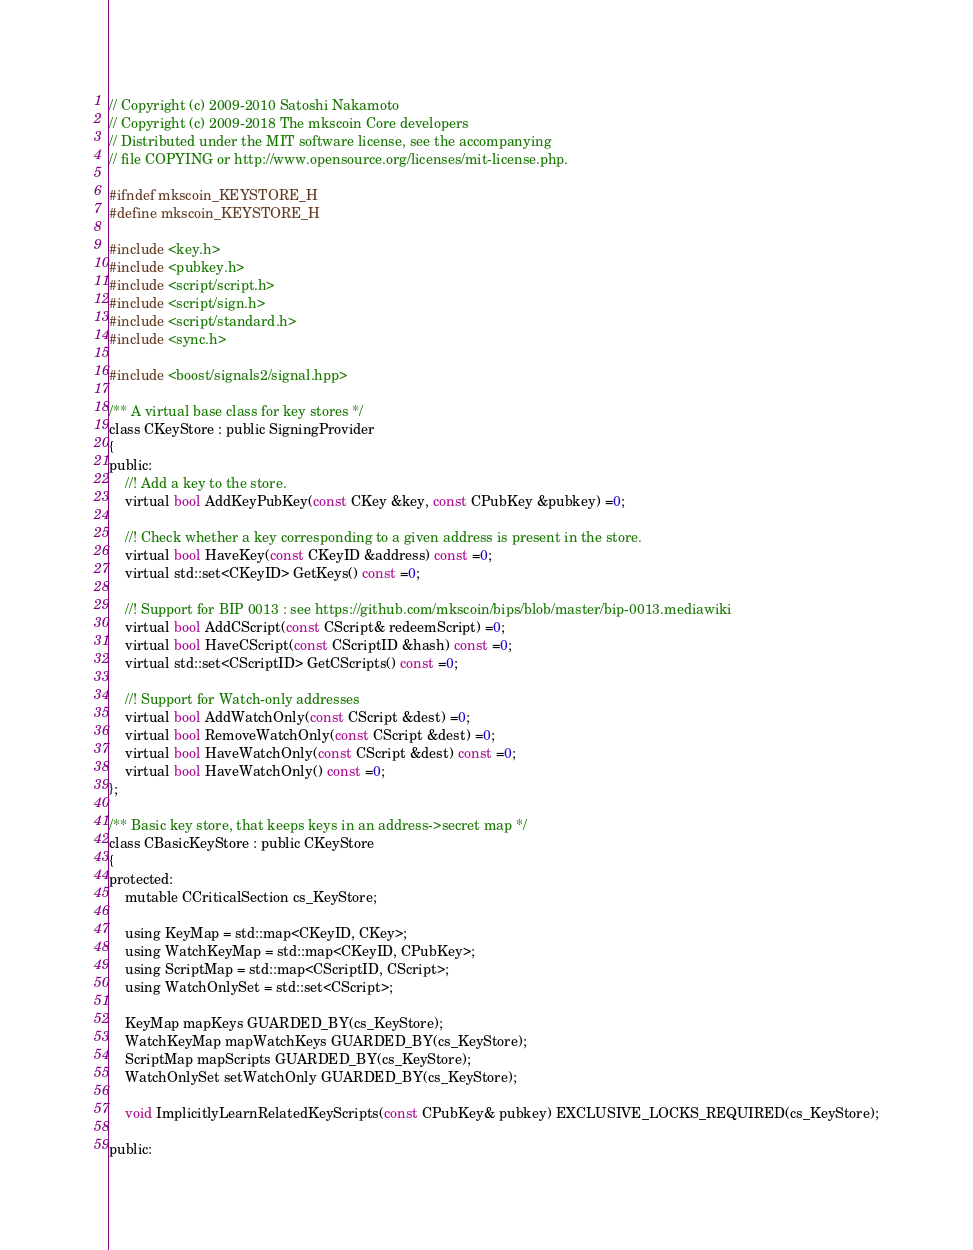<code> <loc_0><loc_0><loc_500><loc_500><_C_>// Copyright (c) 2009-2010 Satoshi Nakamoto
// Copyright (c) 2009-2018 The mkscoin Core developers
// Distributed under the MIT software license, see the accompanying
// file COPYING or http://www.opensource.org/licenses/mit-license.php.

#ifndef mkscoin_KEYSTORE_H
#define mkscoin_KEYSTORE_H

#include <key.h>
#include <pubkey.h>
#include <script/script.h>
#include <script/sign.h>
#include <script/standard.h>
#include <sync.h>

#include <boost/signals2/signal.hpp>

/** A virtual base class for key stores */
class CKeyStore : public SigningProvider
{
public:
    //! Add a key to the store.
    virtual bool AddKeyPubKey(const CKey &key, const CPubKey &pubkey) =0;

    //! Check whether a key corresponding to a given address is present in the store.
    virtual bool HaveKey(const CKeyID &address) const =0;
    virtual std::set<CKeyID> GetKeys() const =0;

    //! Support for BIP 0013 : see https://github.com/mkscoin/bips/blob/master/bip-0013.mediawiki
    virtual bool AddCScript(const CScript& redeemScript) =0;
    virtual bool HaveCScript(const CScriptID &hash) const =0;
    virtual std::set<CScriptID> GetCScripts() const =0;

    //! Support for Watch-only addresses
    virtual bool AddWatchOnly(const CScript &dest) =0;
    virtual bool RemoveWatchOnly(const CScript &dest) =0;
    virtual bool HaveWatchOnly(const CScript &dest) const =0;
    virtual bool HaveWatchOnly() const =0;
};

/** Basic key store, that keeps keys in an address->secret map */
class CBasicKeyStore : public CKeyStore
{
protected:
    mutable CCriticalSection cs_KeyStore;

    using KeyMap = std::map<CKeyID, CKey>;
    using WatchKeyMap = std::map<CKeyID, CPubKey>;
    using ScriptMap = std::map<CScriptID, CScript>;
    using WatchOnlySet = std::set<CScript>;

    KeyMap mapKeys GUARDED_BY(cs_KeyStore);
    WatchKeyMap mapWatchKeys GUARDED_BY(cs_KeyStore);
    ScriptMap mapScripts GUARDED_BY(cs_KeyStore);
    WatchOnlySet setWatchOnly GUARDED_BY(cs_KeyStore);

    void ImplicitlyLearnRelatedKeyScripts(const CPubKey& pubkey) EXCLUSIVE_LOCKS_REQUIRED(cs_KeyStore);

public:</code> 